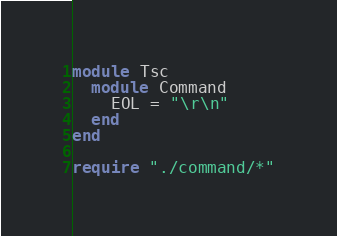Convert code to text. <code><loc_0><loc_0><loc_500><loc_500><_Crystal_>module Tsc
  module Command
    EOL = "\r\n"
  end
end

require "./command/*"
</code> 